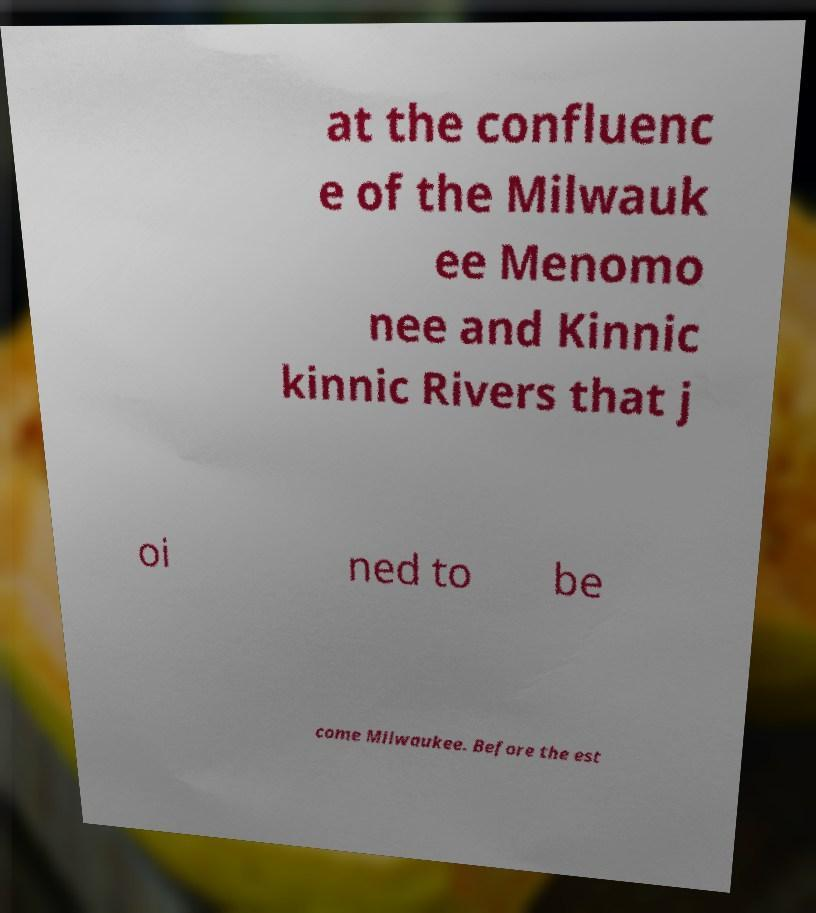Can you accurately transcribe the text from the provided image for me? at the confluenc e of the Milwauk ee Menomo nee and Kinnic kinnic Rivers that j oi ned to be come Milwaukee. Before the est 